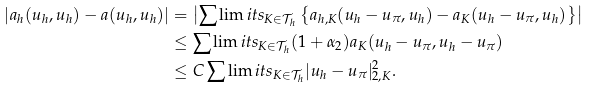<formula> <loc_0><loc_0><loc_500><loc_500>| a _ { h } ( u _ { h } , u _ { h } ) - a ( u _ { h } , u _ { h } ) | & = \left | \sum \lim i t s _ { K \in \mathcal { T } _ { h } } \left \{ a _ { h , K } ( u _ { h } - u _ { \pi } , u _ { h } ) - a _ { K } ( u _ { h } - u _ { \pi } , u _ { h } ) \right \} \right | \\ & \leq \sum \lim i t s _ { K \in \mathcal { T } _ { h } } ( 1 + \alpha _ { 2 } ) a _ { K } ( u _ { h } - u _ { \pi } , u _ { h } - u _ { \pi } ) \\ & \leq C \sum \lim i t s _ { K \in \mathcal { T } _ { h } } | u _ { h } - u _ { \pi } | _ { 2 , K } ^ { 2 } .</formula> 